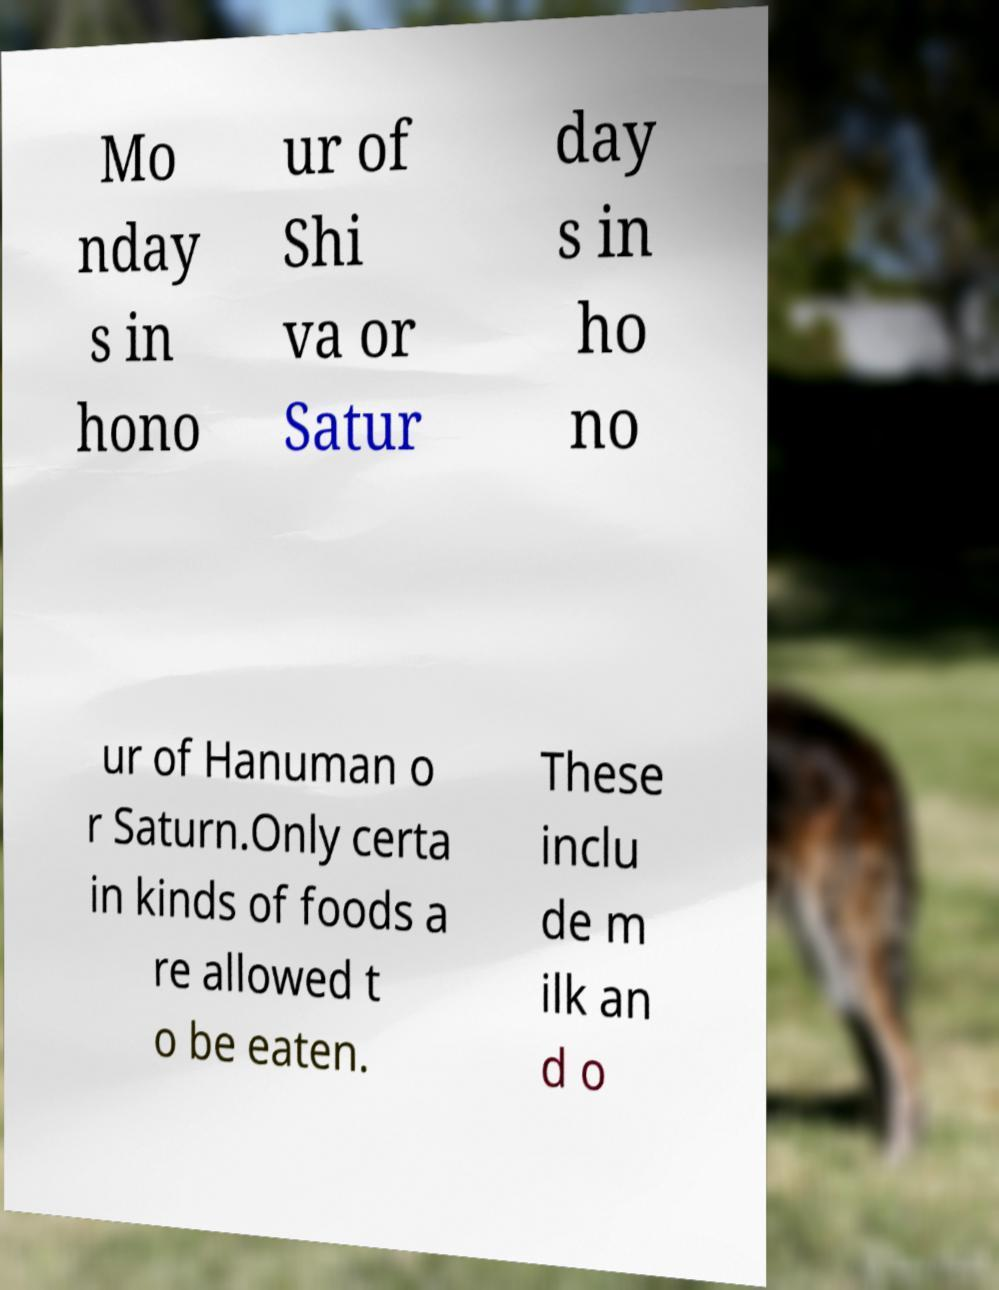For documentation purposes, I need the text within this image transcribed. Could you provide that? Mo nday s in hono ur of Shi va or Satur day s in ho no ur of Hanuman o r Saturn.Only certa in kinds of foods a re allowed t o be eaten. These inclu de m ilk an d o 